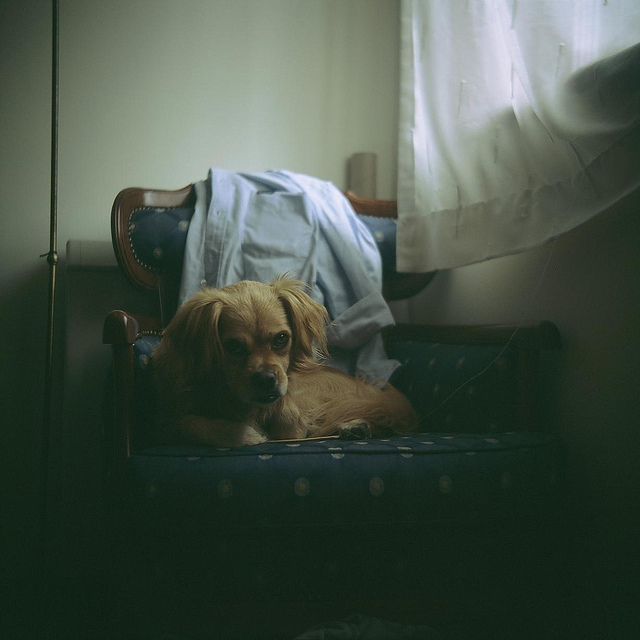<image>What type of dog is this? I don't know what type of dog this is. It could be a dachshund, spaniel, corgi, yorkie, or cocker. What type of dog is this? I am not sure what type of dog it is. It can be seen 'dachshund', 'spaniel', 'corgi', 'yorkie', 'mutt', or 'cocker'. 